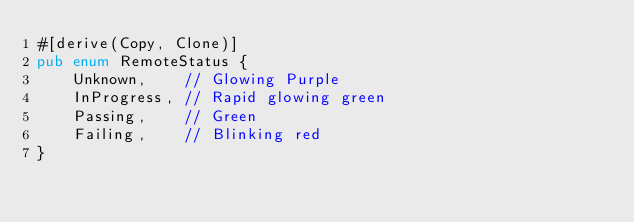Convert code to text. <code><loc_0><loc_0><loc_500><loc_500><_Rust_>#[derive(Copy, Clone)]
pub enum RemoteStatus {
    Unknown,    // Glowing Purple
    InProgress, // Rapid glowing green
    Passing,    // Green
    Failing,    // Blinking red
}
</code> 